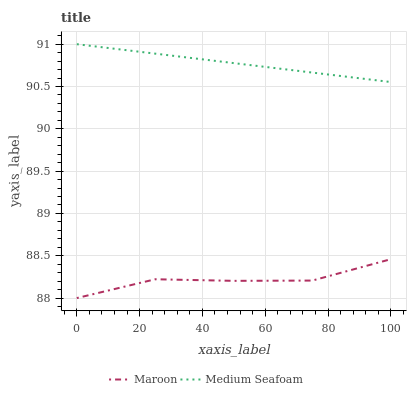Does Maroon have the minimum area under the curve?
Answer yes or no. Yes. Does Medium Seafoam have the maximum area under the curve?
Answer yes or no. Yes. Does Maroon have the maximum area under the curve?
Answer yes or no. No. Is Medium Seafoam the smoothest?
Answer yes or no. Yes. Is Maroon the roughest?
Answer yes or no. Yes. Is Maroon the smoothest?
Answer yes or no. No. Does Maroon have the lowest value?
Answer yes or no. Yes. Does Medium Seafoam have the highest value?
Answer yes or no. Yes. Does Maroon have the highest value?
Answer yes or no. No. Is Maroon less than Medium Seafoam?
Answer yes or no. Yes. Is Medium Seafoam greater than Maroon?
Answer yes or no. Yes. Does Maroon intersect Medium Seafoam?
Answer yes or no. No. 